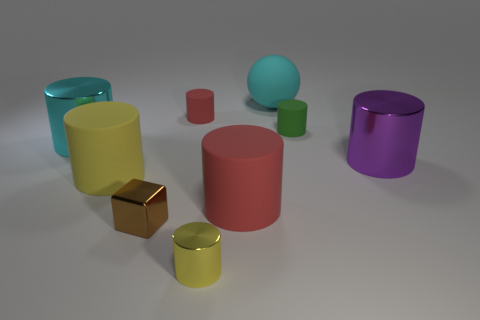The big metal object on the left side of the tiny metallic object left of the tiny yellow cylinder is what shape?
Provide a succinct answer. Cylinder. The cyan metallic thing that is the same size as the purple metal cylinder is what shape?
Your response must be concise. Cylinder. Is there another small block of the same color as the small cube?
Offer a terse response. No. Are there an equal number of cyan matte things that are to the left of the small red thing and cylinders that are behind the cyan cylinder?
Give a very brief answer. No. Does the big red matte thing have the same shape as the large cyan object in front of the small green thing?
Provide a short and direct response. Yes. What number of other objects are the same material as the small brown cube?
Make the answer very short. 3. There is a small green cylinder; are there any big red cylinders to the right of it?
Offer a very short reply. No. There is a yellow rubber cylinder; does it have the same size as the yellow cylinder right of the big yellow cylinder?
Give a very brief answer. No. There is a tiny cylinder in front of the big cyan object that is in front of the big matte sphere; what is its color?
Give a very brief answer. Yellow. Do the cyan metal cylinder and the purple metal thing have the same size?
Offer a terse response. Yes. 